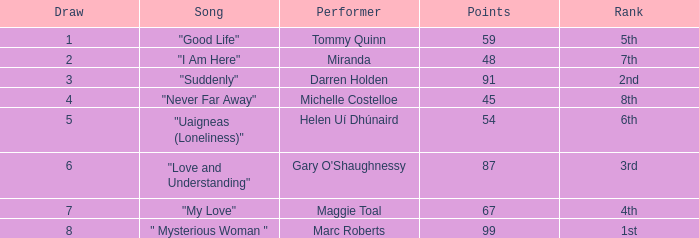What is the total number of draws for songs performed by Miranda with fewer than 48 points? 0.0. 